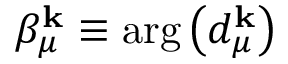<formula> <loc_0><loc_0><loc_500><loc_500>\beta _ { \mu } ^ { k } \equiv \arg \left ( d _ { \mu } ^ { k } \right )</formula> 